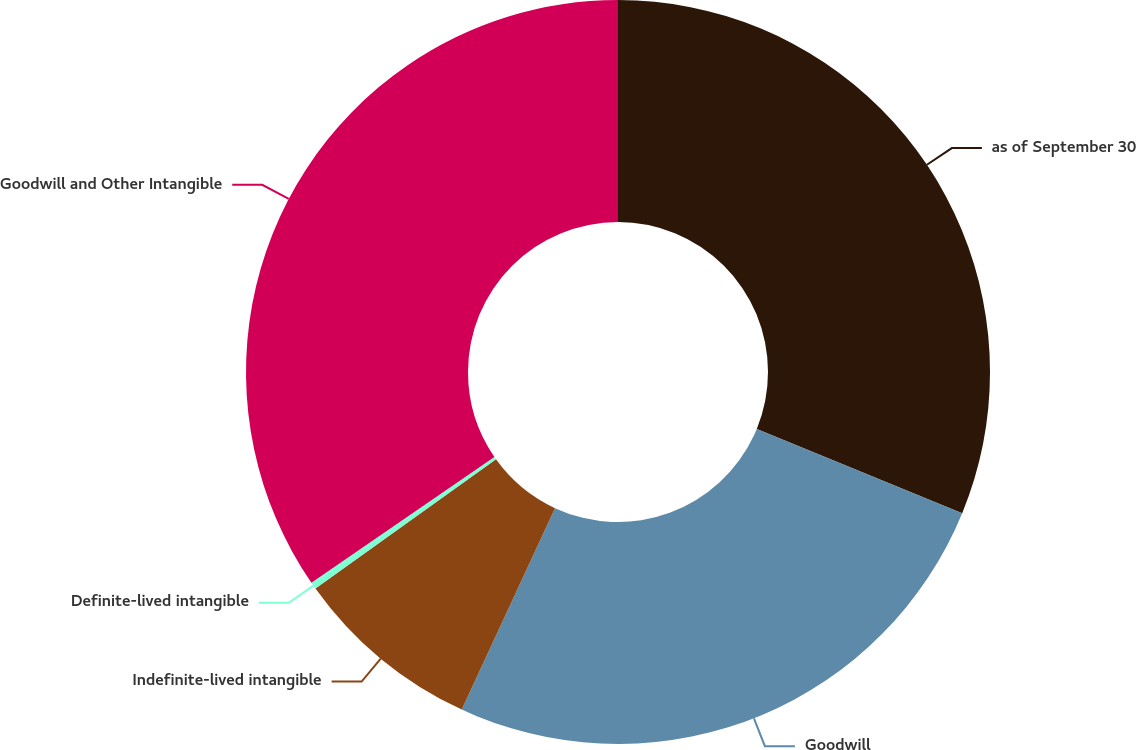<chart> <loc_0><loc_0><loc_500><loc_500><pie_chart><fcel>as of September 30<fcel>Goodwill<fcel>Indefinite-lived intangible<fcel>Definite-lived intangible<fcel>Goodwill and Other Intangible<nl><fcel>31.2%<fcel>25.71%<fcel>8.22%<fcel>0.3%<fcel>34.59%<nl></chart> 